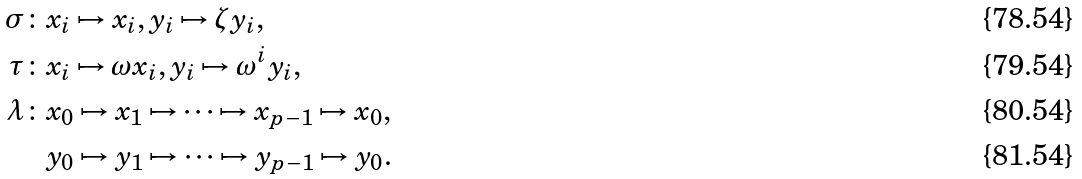Convert formula to latex. <formula><loc_0><loc_0><loc_500><loc_500>\sigma \colon & x _ { i } \mapsto x _ { i } , y _ { i } \mapsto \zeta y _ { i } , \\ \tau \colon & x _ { i } \mapsto \omega x _ { i } , y _ { i } \mapsto \omega ^ { i } y _ { i } , \\ \lambda \colon & x _ { 0 } \mapsto x _ { 1 } \mapsto \cdots \mapsto x _ { p - 1 } \mapsto x _ { 0 } , \\ & y _ { 0 } \mapsto y _ { 1 } \mapsto \cdots \mapsto y _ { p - 1 } \mapsto y _ { 0 } .</formula> 